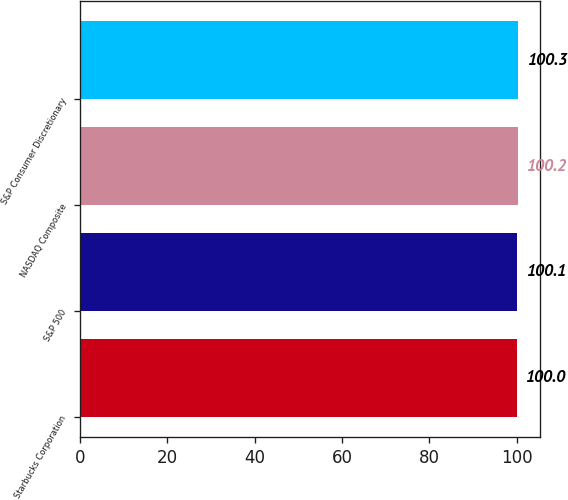Convert chart. <chart><loc_0><loc_0><loc_500><loc_500><bar_chart><fcel>Starbucks Corporation<fcel>S&P 500<fcel>NASDAQ Composite<fcel>S&P Consumer Discretionary<nl><fcel>100<fcel>100.1<fcel>100.2<fcel>100.3<nl></chart> 